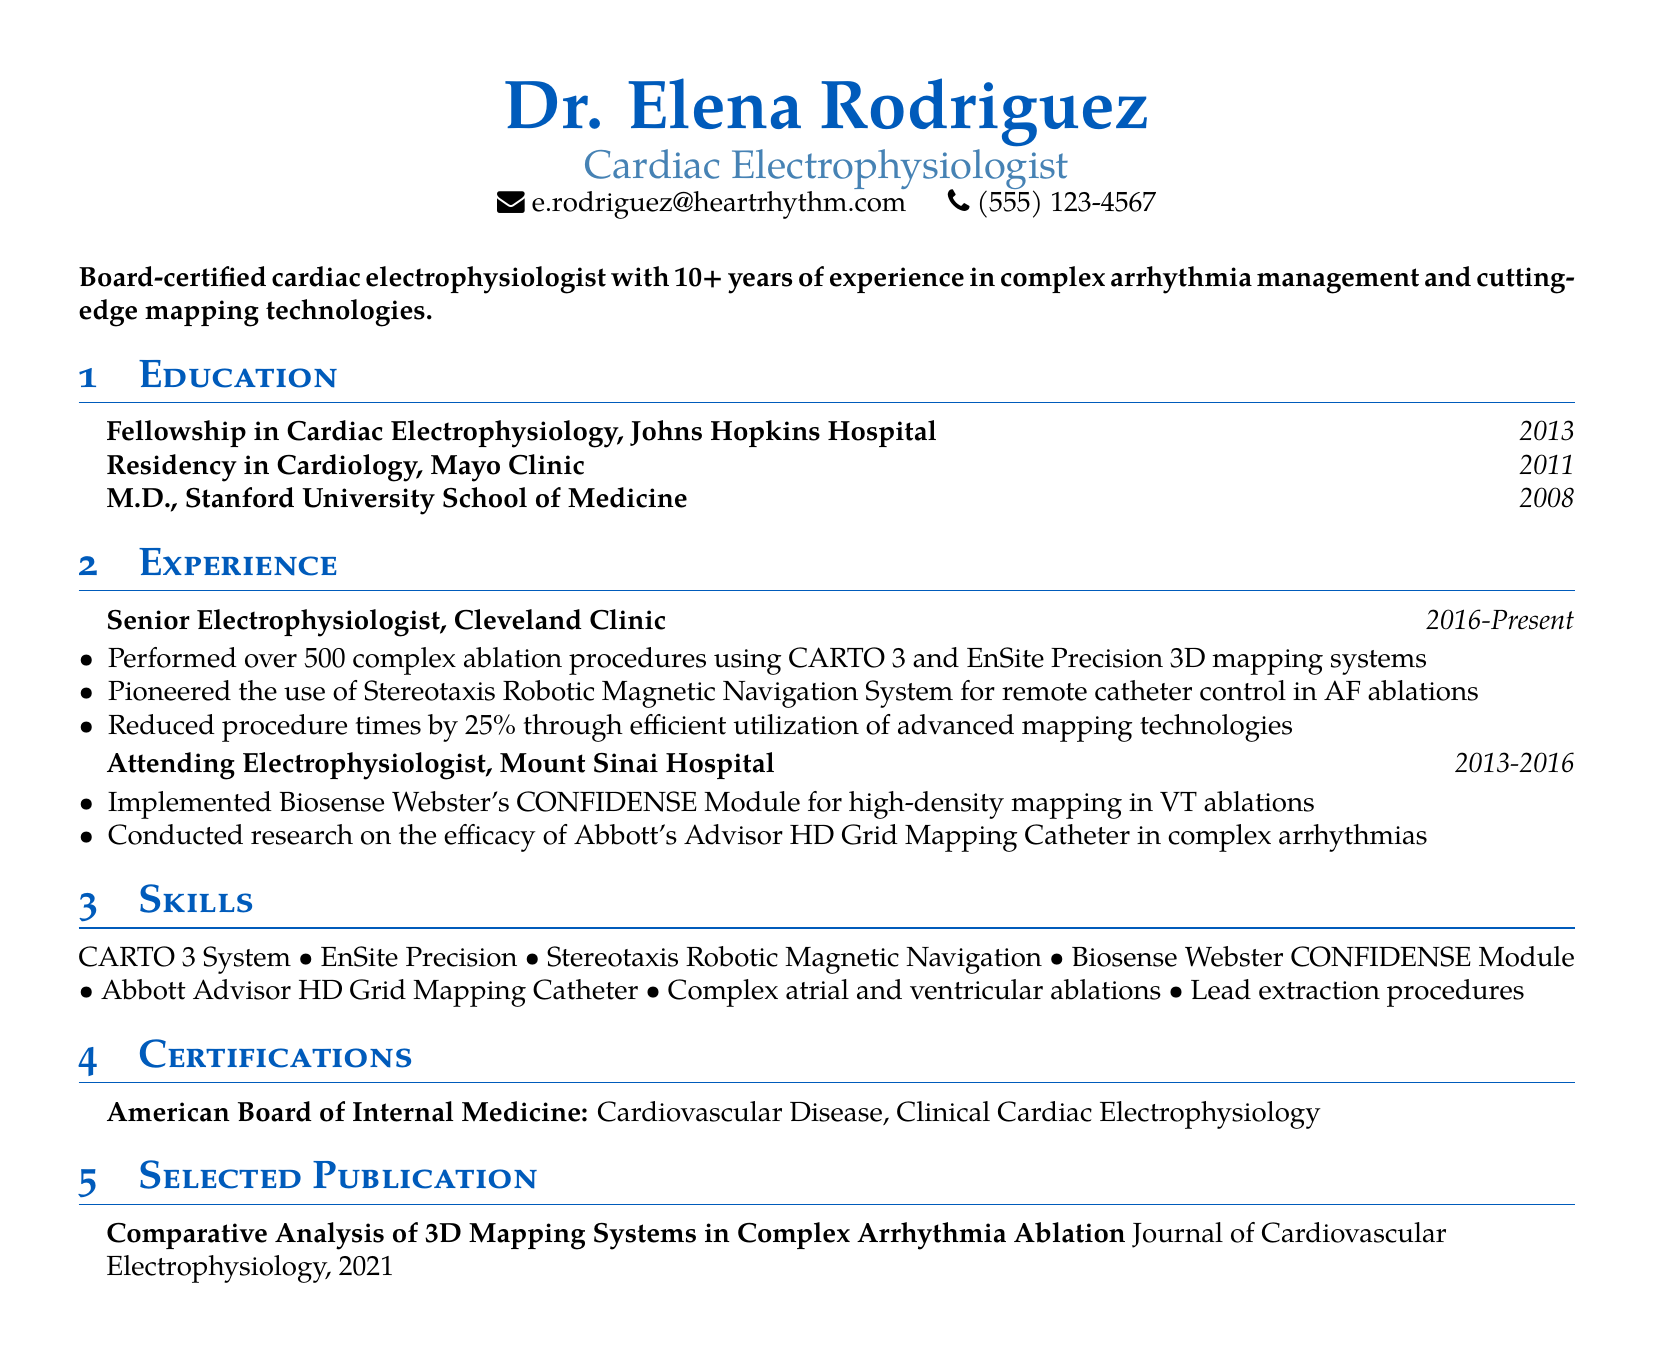What is Dr. Elena Rodriguez's title? The title stated in the document is the professional designation of Dr. Elena Rodriguez.
Answer: Cardiac Electrophysiologist What is the duration of Dr. Rodriguez's experience at the Cleveland Clinic? The document specifies the duration of Dr. Rodriguez's role at the Cleveland Clinic, which is listed as the years of employment.
Answer: 2016-Present How many complex ablation procedures has Dr. Rodriguez performed? The number of complex ablation procedures performed by Dr. Rodriguez is highlighted in her responsibilities at the Cleveland Clinic.
Answer: over 500 Which 3D mapping systems does Dr. Rodriguez use? The document lists the specific 3D mapping systems Dr. Rodriguez has experience with in her current position.
Answer: CARTO 3 and EnSite Precision What certification does Dr. Rodriguez hold related to cardiac electrophysiology? The certification pertaining to cardiac electrophysiology is mentioned in the certifications section of the document.
Answer: Clinical Cardiac Electrophysiology What advanced technology did Dr. Rodriguez pioneer the use of? The document notes a specific technology related to remote catheter navigation that Dr. Rodriguez pioneered during her work.
Answer: Stereotaxis Robotic Magnetic Navigation System In which publication did Dr. Rodriguez analyze 3D mapping systems? The title of the publication is mentioned, focusing on a comparative analysis she conducted.
Answer: Comparative Analysis of 3D Mapping Systems in Complex Arrhythmia Ablation At which institution did Dr. Rodriguez complete her fellowship? The document provides the name of the institution where she completed her fellowship in cardiac electrophysiology.
Answer: Johns Hopkins Hospital What is one of the skills listed that relates to lead extraction? The skills section includes various competencies, one of which pertains to lead extraction procedures.
Answer: Lead extraction procedures 